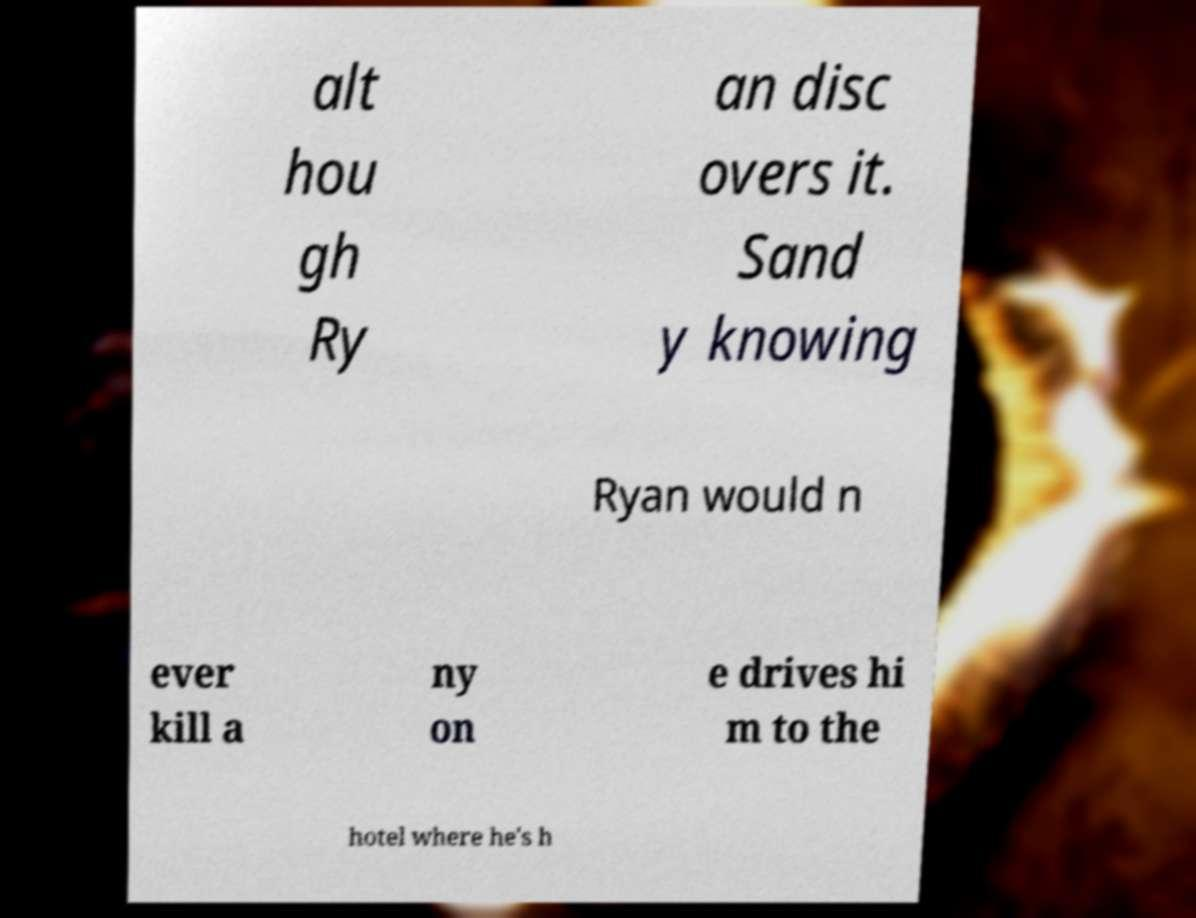I need the written content from this picture converted into text. Can you do that? alt hou gh Ry an disc overs it. Sand y knowing Ryan would n ever kill a ny on e drives hi m to the hotel where he's h 